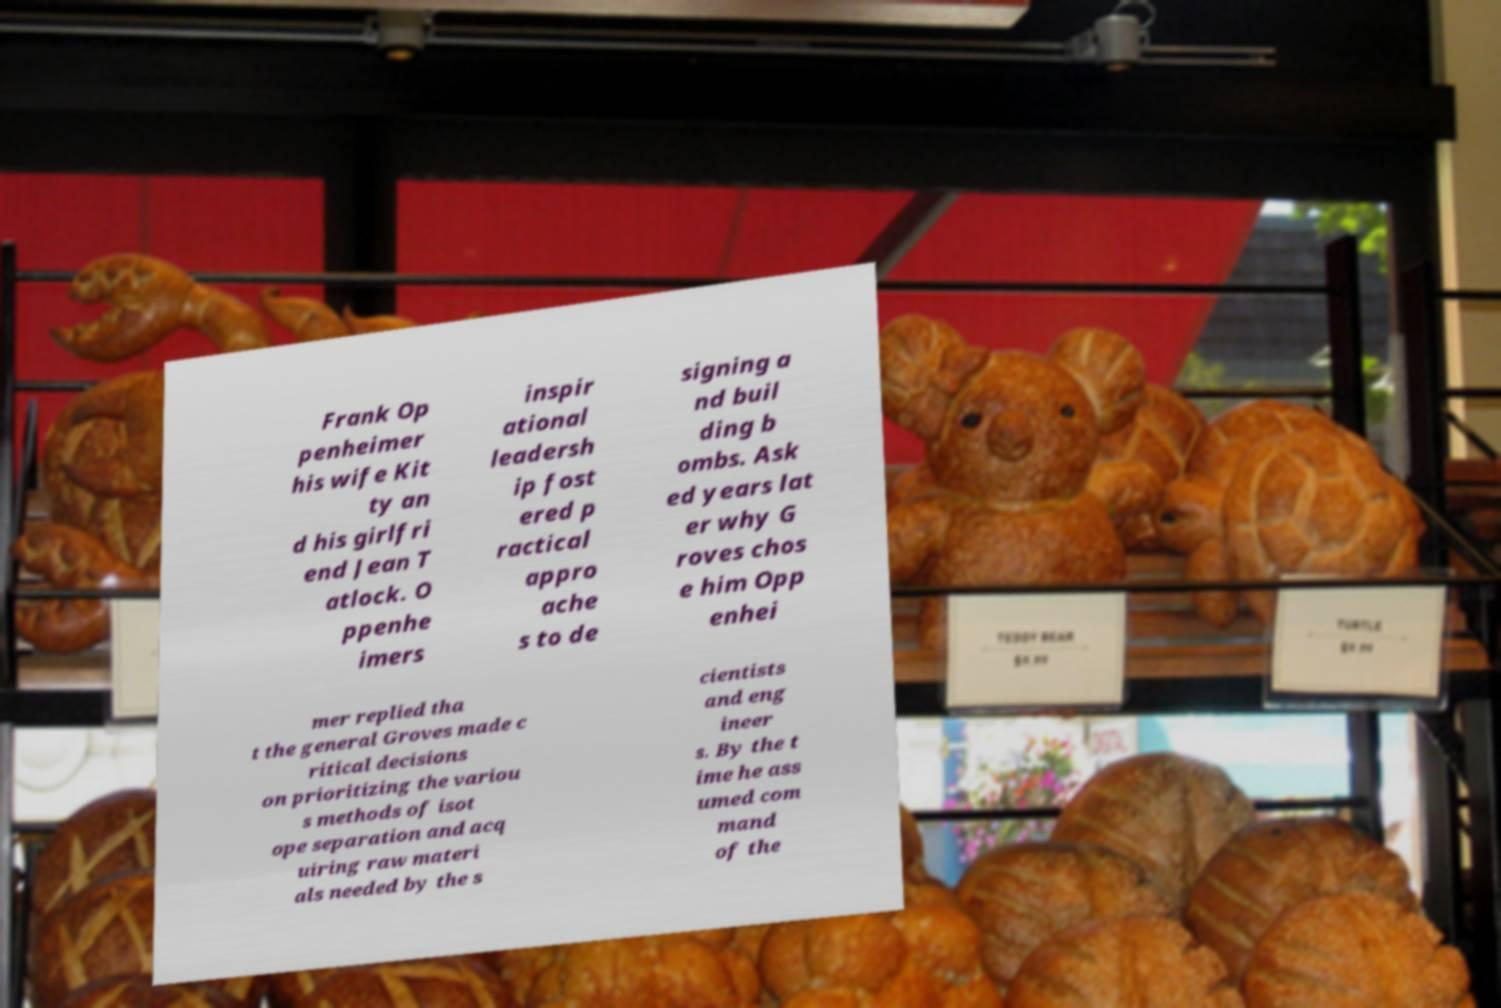Could you extract and type out the text from this image? Frank Op penheimer his wife Kit ty an d his girlfri end Jean T atlock. O ppenhe imers inspir ational leadersh ip fost ered p ractical appro ache s to de signing a nd buil ding b ombs. Ask ed years lat er why G roves chos e him Opp enhei mer replied tha t the general Groves made c ritical decisions on prioritizing the variou s methods of isot ope separation and acq uiring raw materi als needed by the s cientists and eng ineer s. By the t ime he ass umed com mand of the 